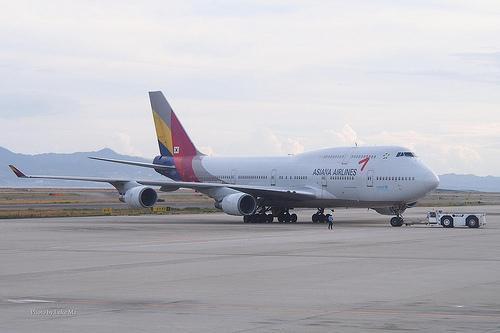How many planes are there?
Give a very brief answer. 1. 